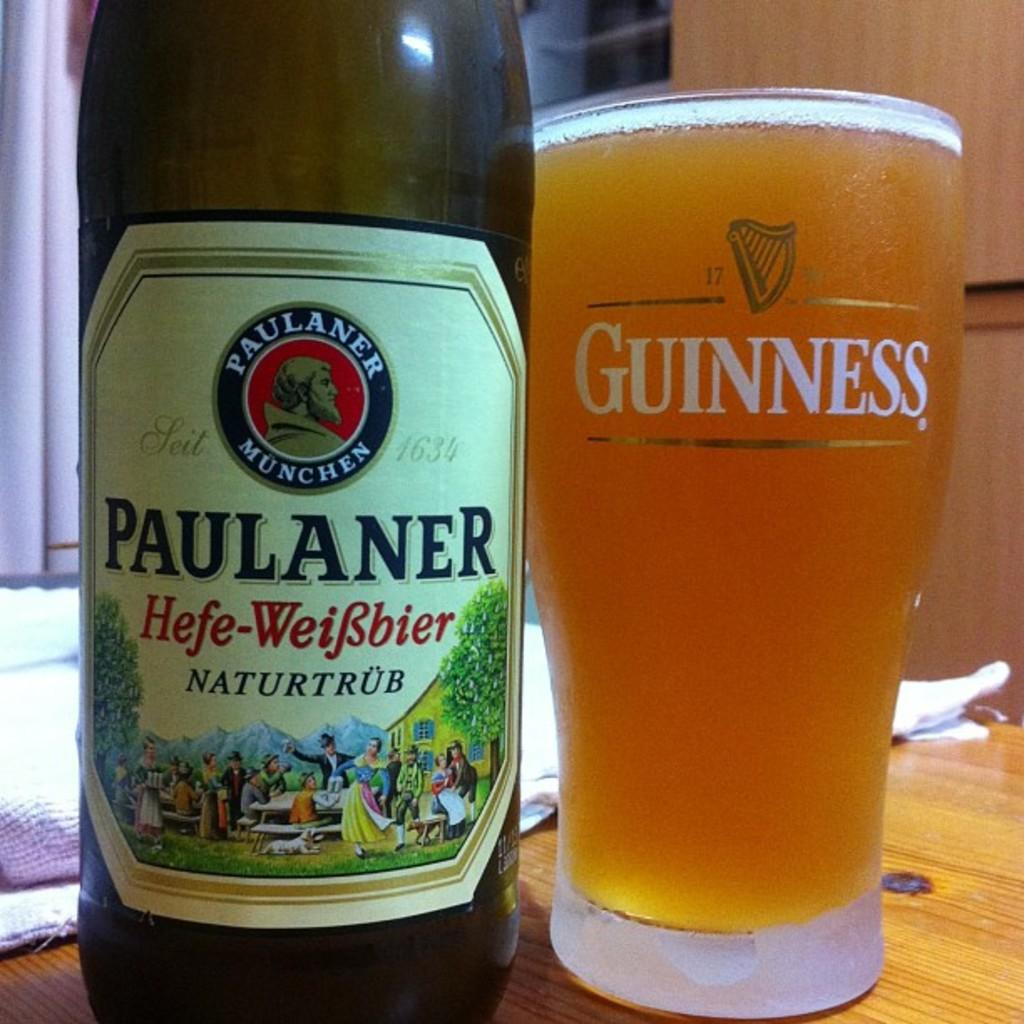<image>
Create a compact narrative representing the image presented. A Paulaner beer bottle and a glass of beer placed side by side. 